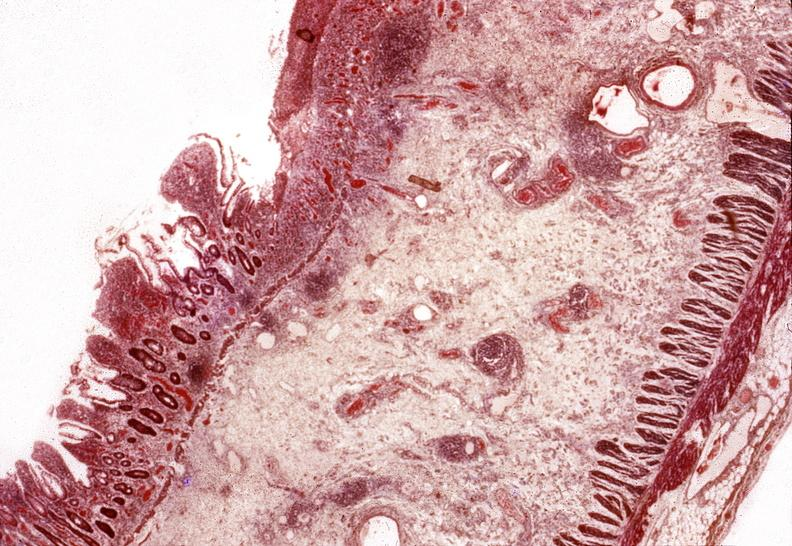s this typical thecoma with yellow foci present?
Answer the question using a single word or phrase. No 